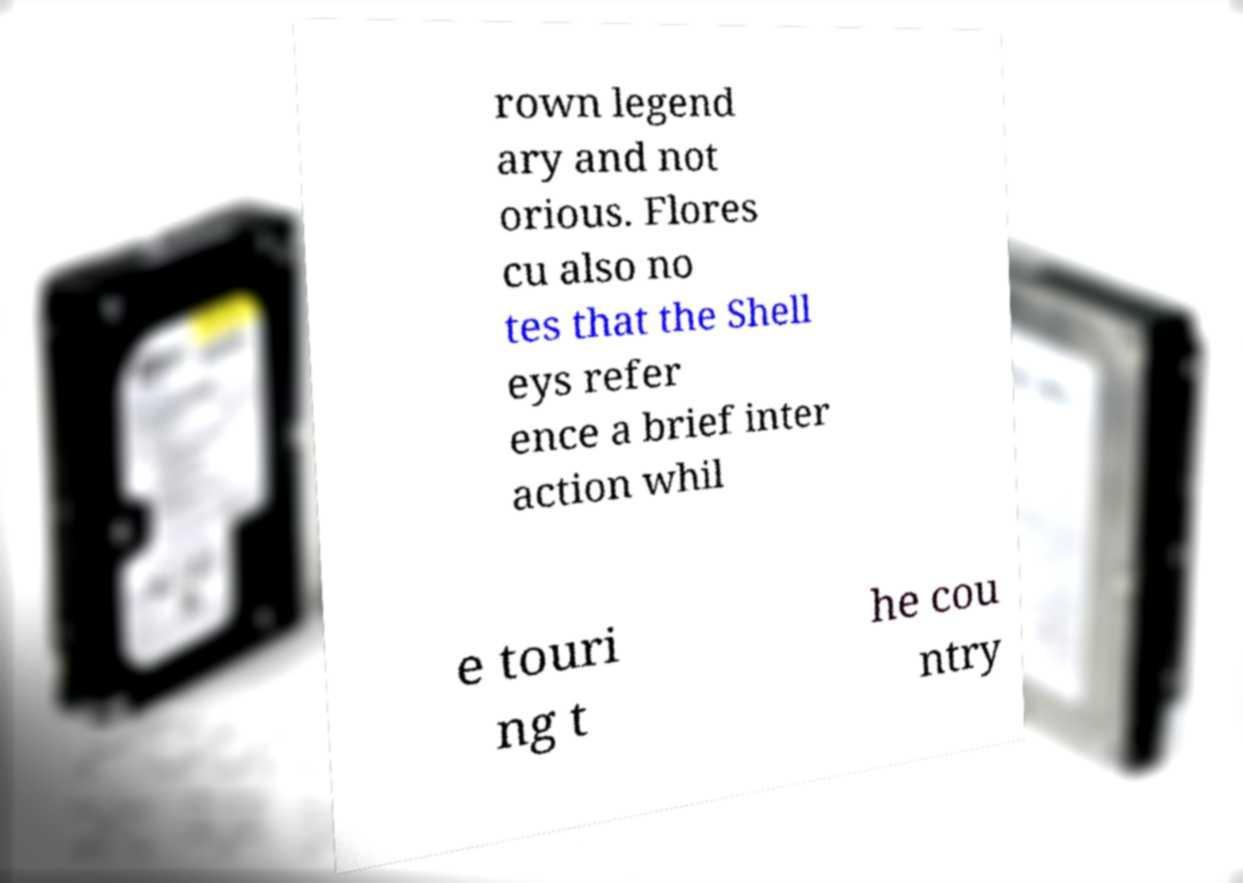Could you extract and type out the text from this image? rown legend ary and not orious. Flores cu also no tes that the Shell eys refer ence a brief inter action whil e touri ng t he cou ntry 